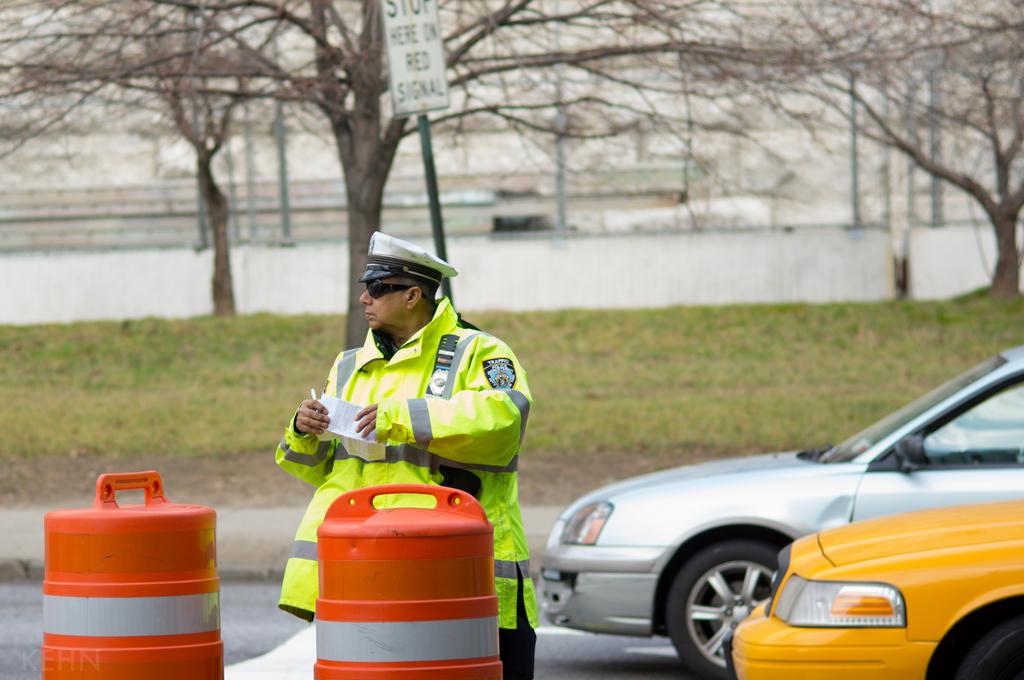What does the street sign read?
Ensure brevity in your answer.  Stop here on red signal. 